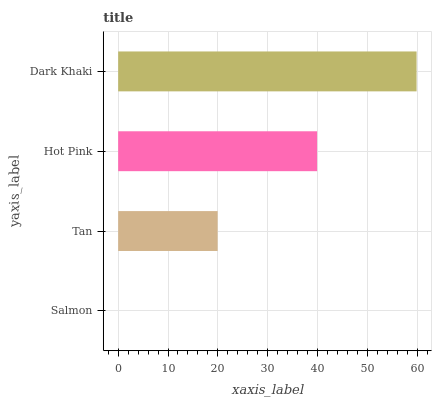Is Salmon the minimum?
Answer yes or no. Yes. Is Dark Khaki the maximum?
Answer yes or no. Yes. Is Tan the minimum?
Answer yes or no. No. Is Tan the maximum?
Answer yes or no. No. Is Tan greater than Salmon?
Answer yes or no. Yes. Is Salmon less than Tan?
Answer yes or no. Yes. Is Salmon greater than Tan?
Answer yes or no. No. Is Tan less than Salmon?
Answer yes or no. No. Is Hot Pink the high median?
Answer yes or no. Yes. Is Tan the low median?
Answer yes or no. Yes. Is Salmon the high median?
Answer yes or no. No. Is Salmon the low median?
Answer yes or no. No. 